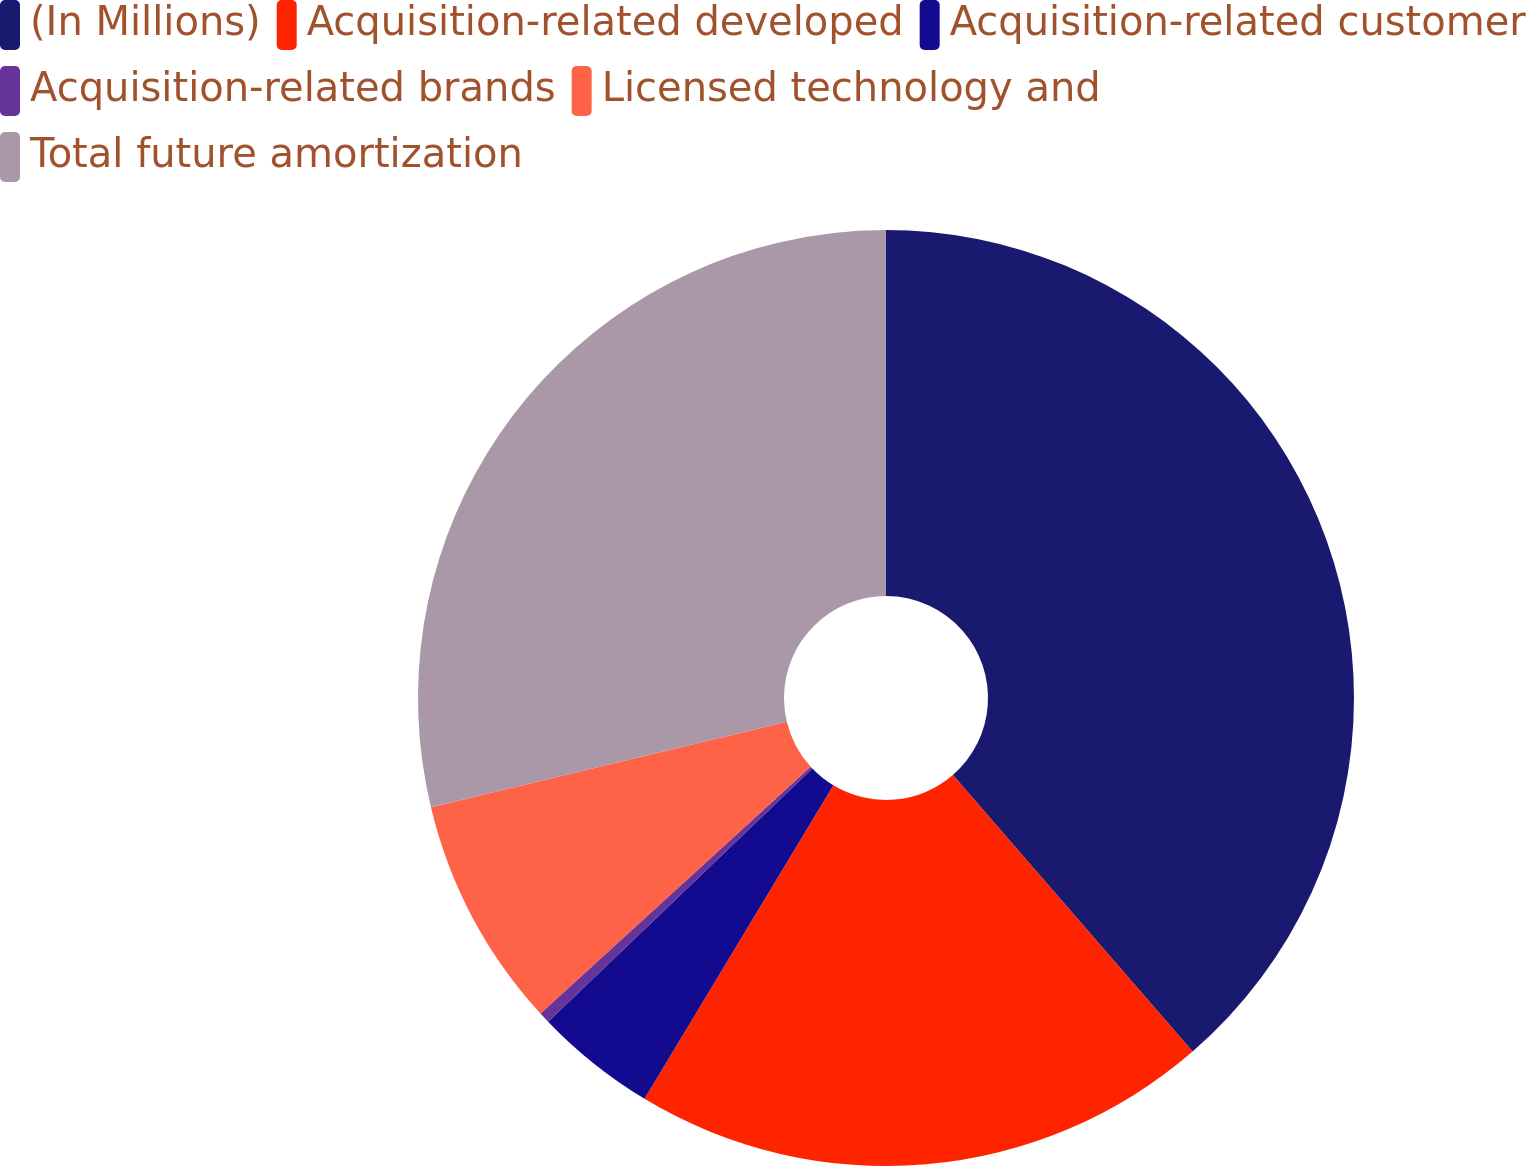<chart> <loc_0><loc_0><loc_500><loc_500><pie_chart><fcel>(In Millions)<fcel>Acquisition-related developed<fcel>Acquisition-related customer<fcel>Acquisition-related brands<fcel>Licensed technology and<fcel>Total future amortization<nl><fcel>38.63%<fcel>20.0%<fcel>4.21%<fcel>0.38%<fcel>8.03%<fcel>28.75%<nl></chart> 